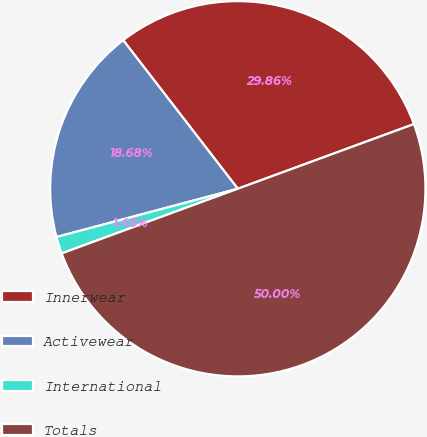Convert chart. <chart><loc_0><loc_0><loc_500><loc_500><pie_chart><fcel>Innerwear<fcel>Activewear<fcel>International<fcel>Totals<nl><fcel>29.86%<fcel>18.68%<fcel>1.46%<fcel>50.0%<nl></chart> 